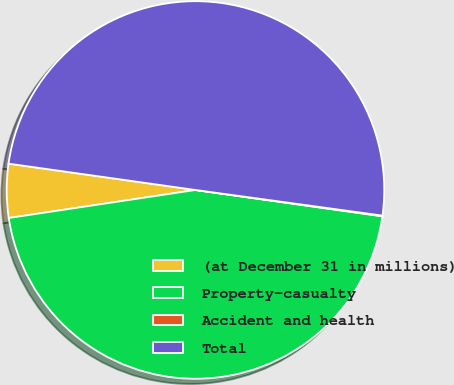Convert chart. <chart><loc_0><loc_0><loc_500><loc_500><pie_chart><fcel>(at December 31 in millions)<fcel>Property-casualty<fcel>Accident and health<fcel>Total<nl><fcel>4.6%<fcel>45.4%<fcel>0.06%<fcel>49.94%<nl></chart> 